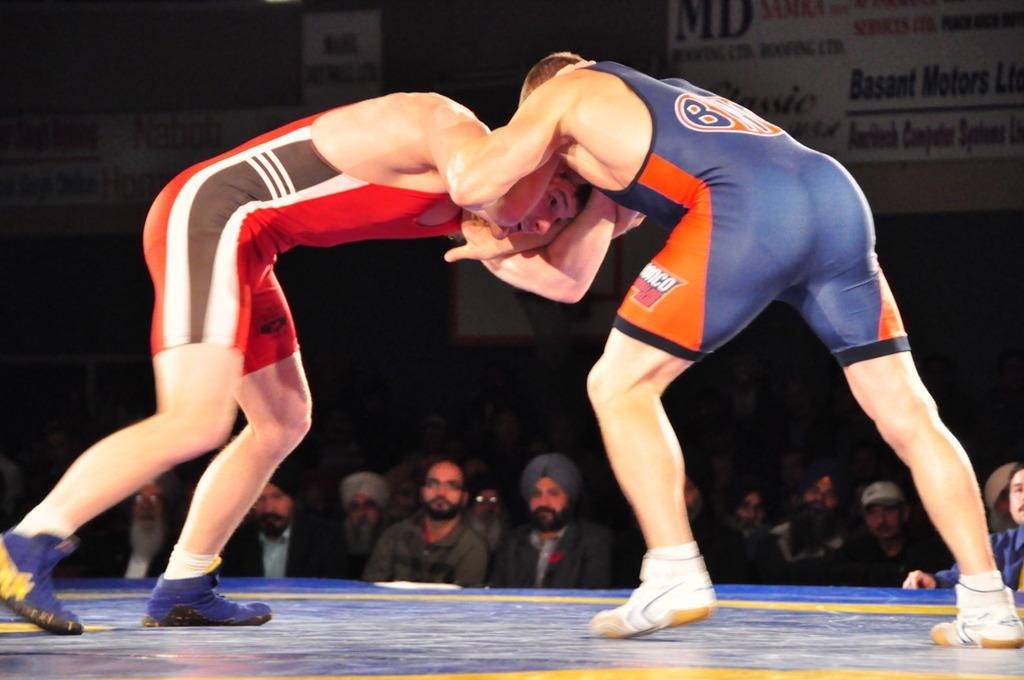<image>
Relay a brief, clear account of the picture shown. Two wrestlers in a headlock with one on the right having the logo for the broncos on his uniform. 